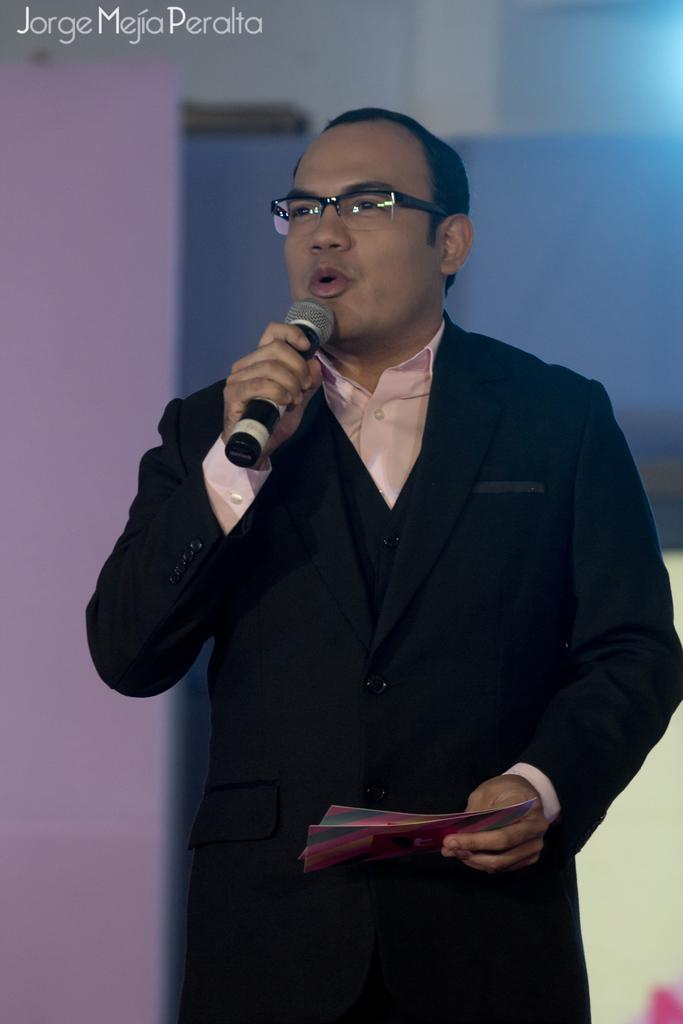What is the main subject of the picture? The main subject of the picture is a man. What is the man doing in the picture? The man is standing and talking. What is the man holding in his hand? The man is holding a microphone and envelopes in his hand. What can be seen on the man's face? The man is wearing spectacles. What type of insurance policy is the man discussing in the cave? There is no cave present in the image, and the man is not discussing any insurance policies. 